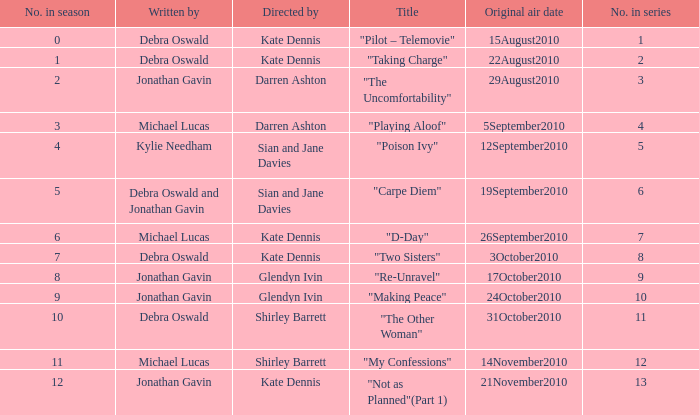When did "My Confessions" first air? 14November2010. 